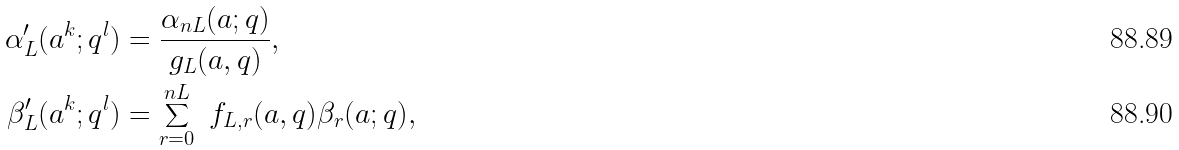Convert formula to latex. <formula><loc_0><loc_0><loc_500><loc_500>\alpha ^ { \prime } _ { L } ( a ^ { k } ; q ^ { l } ) & = \frac { \alpha _ { n L } ( a ; q ) } { g _ { L } ( a , q ) } , \\ \beta ^ { \prime } _ { L } ( a ^ { k } ; q ^ { l } ) & = \sum _ { r = 0 } ^ { n L } \ f _ { L , r } ( a , q ) \beta _ { r } ( a ; q ) ,</formula> 